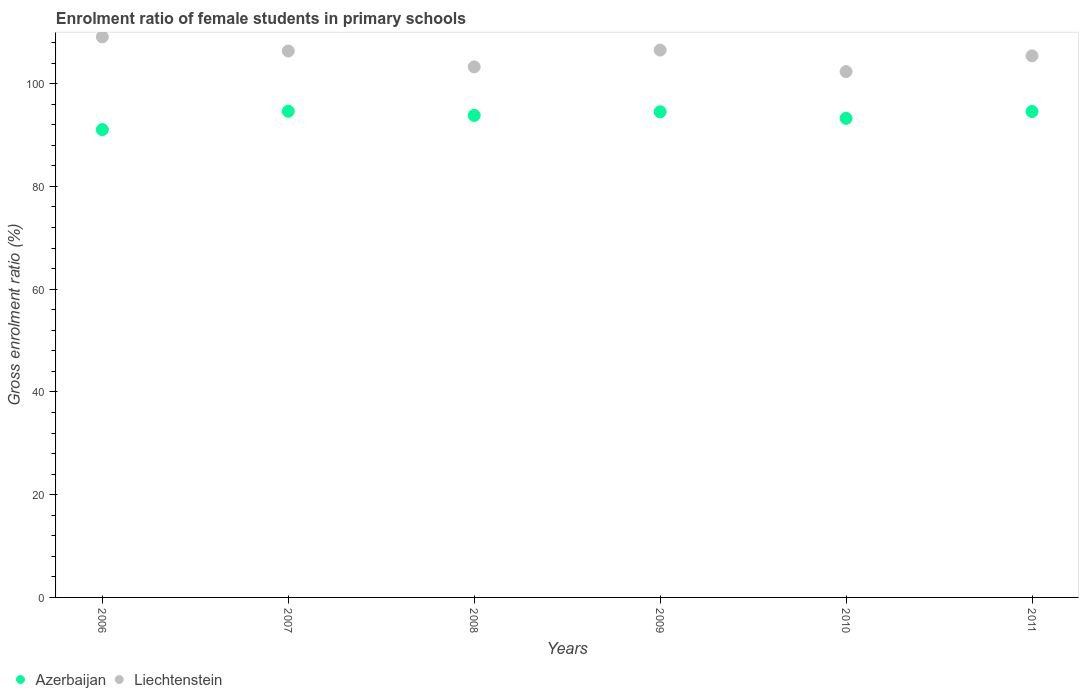How many different coloured dotlines are there?
Offer a terse response. 2. Is the number of dotlines equal to the number of legend labels?
Provide a short and direct response. Yes. What is the enrolment ratio of female students in primary schools in Liechtenstein in 2008?
Your answer should be compact. 103.25. Across all years, what is the maximum enrolment ratio of female students in primary schools in Liechtenstein?
Your answer should be compact. 109.09. Across all years, what is the minimum enrolment ratio of female students in primary schools in Liechtenstein?
Provide a succinct answer. 102.34. In which year was the enrolment ratio of female students in primary schools in Liechtenstein maximum?
Offer a very short reply. 2006. In which year was the enrolment ratio of female students in primary schools in Azerbaijan minimum?
Keep it short and to the point. 2006. What is the total enrolment ratio of female students in primary schools in Liechtenstein in the graph?
Your answer should be very brief. 632.95. What is the difference between the enrolment ratio of female students in primary schools in Liechtenstein in 2007 and that in 2011?
Provide a short and direct response. 0.93. What is the difference between the enrolment ratio of female students in primary schools in Liechtenstein in 2008 and the enrolment ratio of female students in primary schools in Azerbaijan in 2007?
Make the answer very short. 8.64. What is the average enrolment ratio of female students in primary schools in Azerbaijan per year?
Keep it short and to the point. 93.63. In the year 2006, what is the difference between the enrolment ratio of female students in primary schools in Liechtenstein and enrolment ratio of female students in primary schools in Azerbaijan?
Your answer should be very brief. 18.05. In how many years, is the enrolment ratio of female students in primary schools in Azerbaijan greater than 88 %?
Provide a short and direct response. 6. What is the ratio of the enrolment ratio of female students in primary schools in Liechtenstein in 2008 to that in 2009?
Provide a short and direct response. 0.97. Is the difference between the enrolment ratio of female students in primary schools in Liechtenstein in 2007 and 2009 greater than the difference between the enrolment ratio of female students in primary schools in Azerbaijan in 2007 and 2009?
Offer a very short reply. No. What is the difference between the highest and the second highest enrolment ratio of female students in primary schools in Liechtenstein?
Your answer should be compact. 2.57. What is the difference between the highest and the lowest enrolment ratio of female students in primary schools in Azerbaijan?
Give a very brief answer. 3.57. Is the sum of the enrolment ratio of female students in primary schools in Azerbaijan in 2008 and 2010 greater than the maximum enrolment ratio of female students in primary schools in Liechtenstein across all years?
Your response must be concise. Yes. Does the enrolment ratio of female students in primary schools in Azerbaijan monotonically increase over the years?
Give a very brief answer. No. Is the enrolment ratio of female students in primary schools in Azerbaijan strictly less than the enrolment ratio of female students in primary schools in Liechtenstein over the years?
Provide a short and direct response. Yes. Does the graph contain any zero values?
Your response must be concise. No. Where does the legend appear in the graph?
Offer a very short reply. Bottom left. How many legend labels are there?
Your answer should be compact. 2. How are the legend labels stacked?
Your answer should be compact. Horizontal. What is the title of the graph?
Keep it short and to the point. Enrolment ratio of female students in primary schools. What is the label or title of the Y-axis?
Your response must be concise. Gross enrolment ratio (%). What is the Gross enrolment ratio (%) in Azerbaijan in 2006?
Your answer should be compact. 91.04. What is the Gross enrolment ratio (%) in Liechtenstein in 2006?
Your answer should be very brief. 109.09. What is the Gross enrolment ratio (%) of Azerbaijan in 2007?
Offer a very short reply. 94.62. What is the Gross enrolment ratio (%) of Liechtenstein in 2007?
Offer a terse response. 106.34. What is the Gross enrolment ratio (%) of Azerbaijan in 2008?
Offer a terse response. 93.81. What is the Gross enrolment ratio (%) of Liechtenstein in 2008?
Provide a succinct answer. 103.25. What is the Gross enrolment ratio (%) of Azerbaijan in 2009?
Your answer should be very brief. 94.52. What is the Gross enrolment ratio (%) in Liechtenstein in 2009?
Your response must be concise. 106.52. What is the Gross enrolment ratio (%) of Azerbaijan in 2010?
Provide a short and direct response. 93.24. What is the Gross enrolment ratio (%) in Liechtenstein in 2010?
Provide a short and direct response. 102.34. What is the Gross enrolment ratio (%) in Azerbaijan in 2011?
Offer a very short reply. 94.57. What is the Gross enrolment ratio (%) of Liechtenstein in 2011?
Keep it short and to the point. 105.41. Across all years, what is the maximum Gross enrolment ratio (%) in Azerbaijan?
Make the answer very short. 94.62. Across all years, what is the maximum Gross enrolment ratio (%) in Liechtenstein?
Provide a short and direct response. 109.09. Across all years, what is the minimum Gross enrolment ratio (%) of Azerbaijan?
Your answer should be very brief. 91.04. Across all years, what is the minimum Gross enrolment ratio (%) of Liechtenstein?
Ensure brevity in your answer.  102.34. What is the total Gross enrolment ratio (%) in Azerbaijan in the graph?
Give a very brief answer. 561.79. What is the total Gross enrolment ratio (%) in Liechtenstein in the graph?
Make the answer very short. 632.95. What is the difference between the Gross enrolment ratio (%) in Azerbaijan in 2006 and that in 2007?
Your response must be concise. -3.57. What is the difference between the Gross enrolment ratio (%) of Liechtenstein in 2006 and that in 2007?
Provide a short and direct response. 2.75. What is the difference between the Gross enrolment ratio (%) in Azerbaijan in 2006 and that in 2008?
Provide a short and direct response. -2.76. What is the difference between the Gross enrolment ratio (%) of Liechtenstein in 2006 and that in 2008?
Ensure brevity in your answer.  5.84. What is the difference between the Gross enrolment ratio (%) in Azerbaijan in 2006 and that in 2009?
Give a very brief answer. -3.48. What is the difference between the Gross enrolment ratio (%) in Liechtenstein in 2006 and that in 2009?
Provide a succinct answer. 2.57. What is the difference between the Gross enrolment ratio (%) in Azerbaijan in 2006 and that in 2010?
Offer a very short reply. -2.19. What is the difference between the Gross enrolment ratio (%) of Liechtenstein in 2006 and that in 2010?
Your answer should be compact. 6.75. What is the difference between the Gross enrolment ratio (%) in Azerbaijan in 2006 and that in 2011?
Offer a terse response. -3.53. What is the difference between the Gross enrolment ratio (%) of Liechtenstein in 2006 and that in 2011?
Your answer should be very brief. 3.68. What is the difference between the Gross enrolment ratio (%) in Azerbaijan in 2007 and that in 2008?
Your answer should be compact. 0.81. What is the difference between the Gross enrolment ratio (%) in Liechtenstein in 2007 and that in 2008?
Ensure brevity in your answer.  3.09. What is the difference between the Gross enrolment ratio (%) in Azerbaijan in 2007 and that in 2009?
Offer a terse response. 0.09. What is the difference between the Gross enrolment ratio (%) in Liechtenstein in 2007 and that in 2009?
Your response must be concise. -0.18. What is the difference between the Gross enrolment ratio (%) of Azerbaijan in 2007 and that in 2010?
Make the answer very short. 1.38. What is the difference between the Gross enrolment ratio (%) of Liechtenstein in 2007 and that in 2010?
Offer a very short reply. 4. What is the difference between the Gross enrolment ratio (%) in Azerbaijan in 2007 and that in 2011?
Your response must be concise. 0.04. What is the difference between the Gross enrolment ratio (%) in Liechtenstein in 2007 and that in 2011?
Your answer should be compact. 0.93. What is the difference between the Gross enrolment ratio (%) in Azerbaijan in 2008 and that in 2009?
Ensure brevity in your answer.  -0.71. What is the difference between the Gross enrolment ratio (%) in Liechtenstein in 2008 and that in 2009?
Your response must be concise. -3.27. What is the difference between the Gross enrolment ratio (%) of Azerbaijan in 2008 and that in 2010?
Provide a succinct answer. 0.57. What is the difference between the Gross enrolment ratio (%) in Liechtenstein in 2008 and that in 2010?
Offer a terse response. 0.91. What is the difference between the Gross enrolment ratio (%) of Azerbaijan in 2008 and that in 2011?
Offer a very short reply. -0.76. What is the difference between the Gross enrolment ratio (%) in Liechtenstein in 2008 and that in 2011?
Provide a short and direct response. -2.16. What is the difference between the Gross enrolment ratio (%) in Azerbaijan in 2009 and that in 2010?
Offer a terse response. 1.28. What is the difference between the Gross enrolment ratio (%) of Liechtenstein in 2009 and that in 2010?
Keep it short and to the point. 4.18. What is the difference between the Gross enrolment ratio (%) in Azerbaijan in 2009 and that in 2011?
Keep it short and to the point. -0.05. What is the difference between the Gross enrolment ratio (%) of Liechtenstein in 2009 and that in 2011?
Your answer should be very brief. 1.11. What is the difference between the Gross enrolment ratio (%) of Azerbaijan in 2010 and that in 2011?
Ensure brevity in your answer.  -1.33. What is the difference between the Gross enrolment ratio (%) of Liechtenstein in 2010 and that in 2011?
Provide a succinct answer. -3.07. What is the difference between the Gross enrolment ratio (%) in Azerbaijan in 2006 and the Gross enrolment ratio (%) in Liechtenstein in 2007?
Keep it short and to the point. -15.29. What is the difference between the Gross enrolment ratio (%) of Azerbaijan in 2006 and the Gross enrolment ratio (%) of Liechtenstein in 2008?
Your answer should be compact. -12.21. What is the difference between the Gross enrolment ratio (%) in Azerbaijan in 2006 and the Gross enrolment ratio (%) in Liechtenstein in 2009?
Offer a very short reply. -15.48. What is the difference between the Gross enrolment ratio (%) in Azerbaijan in 2006 and the Gross enrolment ratio (%) in Liechtenstein in 2010?
Your answer should be compact. -11.29. What is the difference between the Gross enrolment ratio (%) of Azerbaijan in 2006 and the Gross enrolment ratio (%) of Liechtenstein in 2011?
Offer a terse response. -14.37. What is the difference between the Gross enrolment ratio (%) in Azerbaijan in 2007 and the Gross enrolment ratio (%) in Liechtenstein in 2008?
Your answer should be very brief. -8.64. What is the difference between the Gross enrolment ratio (%) of Azerbaijan in 2007 and the Gross enrolment ratio (%) of Liechtenstein in 2009?
Provide a succinct answer. -11.91. What is the difference between the Gross enrolment ratio (%) of Azerbaijan in 2007 and the Gross enrolment ratio (%) of Liechtenstein in 2010?
Give a very brief answer. -7.72. What is the difference between the Gross enrolment ratio (%) of Azerbaijan in 2007 and the Gross enrolment ratio (%) of Liechtenstein in 2011?
Offer a terse response. -10.79. What is the difference between the Gross enrolment ratio (%) in Azerbaijan in 2008 and the Gross enrolment ratio (%) in Liechtenstein in 2009?
Give a very brief answer. -12.71. What is the difference between the Gross enrolment ratio (%) of Azerbaijan in 2008 and the Gross enrolment ratio (%) of Liechtenstein in 2010?
Your answer should be compact. -8.53. What is the difference between the Gross enrolment ratio (%) of Azerbaijan in 2008 and the Gross enrolment ratio (%) of Liechtenstein in 2011?
Your response must be concise. -11.6. What is the difference between the Gross enrolment ratio (%) of Azerbaijan in 2009 and the Gross enrolment ratio (%) of Liechtenstein in 2010?
Make the answer very short. -7.82. What is the difference between the Gross enrolment ratio (%) of Azerbaijan in 2009 and the Gross enrolment ratio (%) of Liechtenstein in 2011?
Provide a succinct answer. -10.89. What is the difference between the Gross enrolment ratio (%) of Azerbaijan in 2010 and the Gross enrolment ratio (%) of Liechtenstein in 2011?
Give a very brief answer. -12.17. What is the average Gross enrolment ratio (%) of Azerbaijan per year?
Offer a very short reply. 93.63. What is the average Gross enrolment ratio (%) of Liechtenstein per year?
Provide a succinct answer. 105.49. In the year 2006, what is the difference between the Gross enrolment ratio (%) in Azerbaijan and Gross enrolment ratio (%) in Liechtenstein?
Offer a terse response. -18.05. In the year 2007, what is the difference between the Gross enrolment ratio (%) in Azerbaijan and Gross enrolment ratio (%) in Liechtenstein?
Provide a short and direct response. -11.72. In the year 2008, what is the difference between the Gross enrolment ratio (%) in Azerbaijan and Gross enrolment ratio (%) in Liechtenstein?
Provide a succinct answer. -9.44. In the year 2009, what is the difference between the Gross enrolment ratio (%) of Azerbaijan and Gross enrolment ratio (%) of Liechtenstein?
Your answer should be very brief. -12. In the year 2010, what is the difference between the Gross enrolment ratio (%) of Azerbaijan and Gross enrolment ratio (%) of Liechtenstein?
Offer a very short reply. -9.1. In the year 2011, what is the difference between the Gross enrolment ratio (%) in Azerbaijan and Gross enrolment ratio (%) in Liechtenstein?
Your answer should be compact. -10.84. What is the ratio of the Gross enrolment ratio (%) in Azerbaijan in 2006 to that in 2007?
Offer a very short reply. 0.96. What is the ratio of the Gross enrolment ratio (%) of Liechtenstein in 2006 to that in 2007?
Your answer should be very brief. 1.03. What is the ratio of the Gross enrolment ratio (%) of Azerbaijan in 2006 to that in 2008?
Provide a succinct answer. 0.97. What is the ratio of the Gross enrolment ratio (%) in Liechtenstein in 2006 to that in 2008?
Ensure brevity in your answer.  1.06. What is the ratio of the Gross enrolment ratio (%) in Azerbaijan in 2006 to that in 2009?
Your response must be concise. 0.96. What is the ratio of the Gross enrolment ratio (%) in Liechtenstein in 2006 to that in 2009?
Provide a succinct answer. 1.02. What is the ratio of the Gross enrolment ratio (%) of Azerbaijan in 2006 to that in 2010?
Ensure brevity in your answer.  0.98. What is the ratio of the Gross enrolment ratio (%) of Liechtenstein in 2006 to that in 2010?
Keep it short and to the point. 1.07. What is the ratio of the Gross enrolment ratio (%) of Azerbaijan in 2006 to that in 2011?
Provide a short and direct response. 0.96. What is the ratio of the Gross enrolment ratio (%) in Liechtenstein in 2006 to that in 2011?
Your response must be concise. 1.03. What is the ratio of the Gross enrolment ratio (%) of Azerbaijan in 2007 to that in 2008?
Your answer should be very brief. 1.01. What is the ratio of the Gross enrolment ratio (%) in Liechtenstein in 2007 to that in 2008?
Provide a succinct answer. 1.03. What is the ratio of the Gross enrolment ratio (%) of Liechtenstein in 2007 to that in 2009?
Offer a very short reply. 1. What is the ratio of the Gross enrolment ratio (%) in Azerbaijan in 2007 to that in 2010?
Keep it short and to the point. 1.01. What is the ratio of the Gross enrolment ratio (%) of Liechtenstein in 2007 to that in 2010?
Offer a terse response. 1.04. What is the ratio of the Gross enrolment ratio (%) in Liechtenstein in 2007 to that in 2011?
Offer a terse response. 1.01. What is the ratio of the Gross enrolment ratio (%) of Azerbaijan in 2008 to that in 2009?
Make the answer very short. 0.99. What is the ratio of the Gross enrolment ratio (%) in Liechtenstein in 2008 to that in 2009?
Keep it short and to the point. 0.97. What is the ratio of the Gross enrolment ratio (%) in Azerbaijan in 2008 to that in 2010?
Keep it short and to the point. 1.01. What is the ratio of the Gross enrolment ratio (%) of Liechtenstein in 2008 to that in 2010?
Your answer should be compact. 1.01. What is the ratio of the Gross enrolment ratio (%) in Azerbaijan in 2008 to that in 2011?
Offer a very short reply. 0.99. What is the ratio of the Gross enrolment ratio (%) in Liechtenstein in 2008 to that in 2011?
Give a very brief answer. 0.98. What is the ratio of the Gross enrolment ratio (%) of Azerbaijan in 2009 to that in 2010?
Ensure brevity in your answer.  1.01. What is the ratio of the Gross enrolment ratio (%) in Liechtenstein in 2009 to that in 2010?
Ensure brevity in your answer.  1.04. What is the ratio of the Gross enrolment ratio (%) of Liechtenstein in 2009 to that in 2011?
Ensure brevity in your answer.  1.01. What is the ratio of the Gross enrolment ratio (%) in Azerbaijan in 2010 to that in 2011?
Provide a succinct answer. 0.99. What is the ratio of the Gross enrolment ratio (%) of Liechtenstein in 2010 to that in 2011?
Provide a short and direct response. 0.97. What is the difference between the highest and the second highest Gross enrolment ratio (%) in Azerbaijan?
Ensure brevity in your answer.  0.04. What is the difference between the highest and the second highest Gross enrolment ratio (%) of Liechtenstein?
Your answer should be very brief. 2.57. What is the difference between the highest and the lowest Gross enrolment ratio (%) of Azerbaijan?
Your answer should be very brief. 3.57. What is the difference between the highest and the lowest Gross enrolment ratio (%) in Liechtenstein?
Your answer should be very brief. 6.75. 